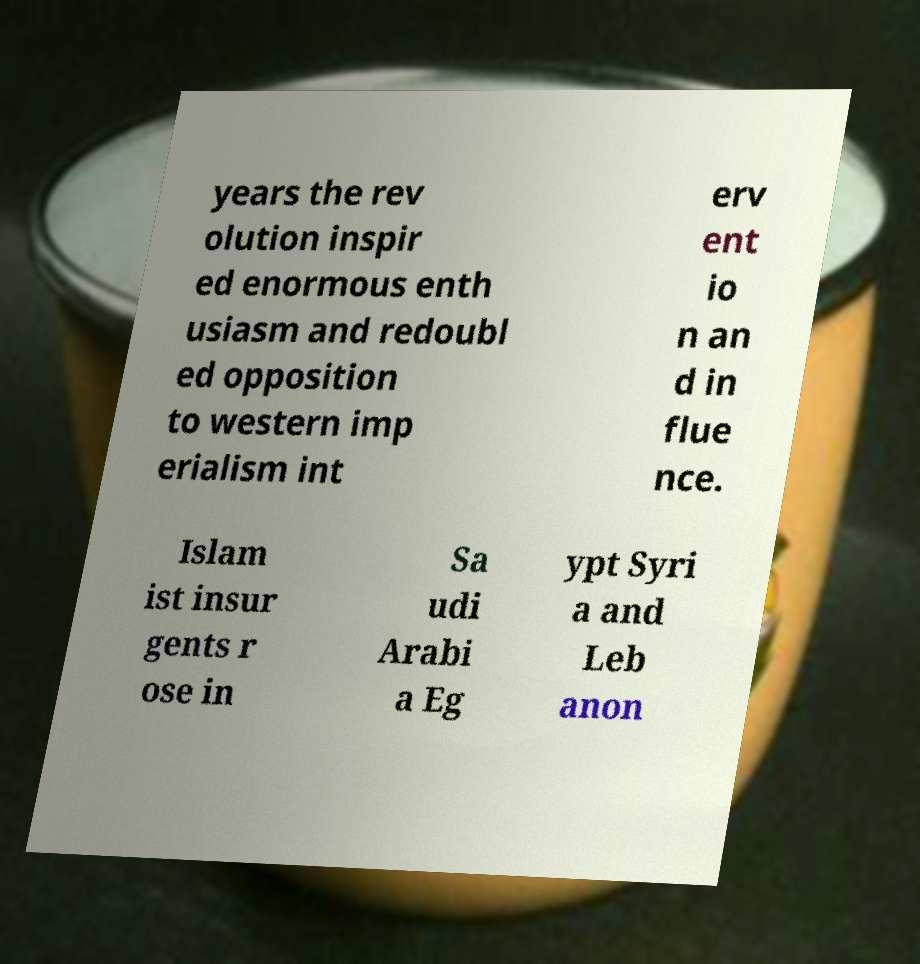Can you accurately transcribe the text from the provided image for me? years the rev olution inspir ed enormous enth usiasm and redoubl ed opposition to western imp erialism int erv ent io n an d in flue nce. Islam ist insur gents r ose in Sa udi Arabi a Eg ypt Syri a and Leb anon 